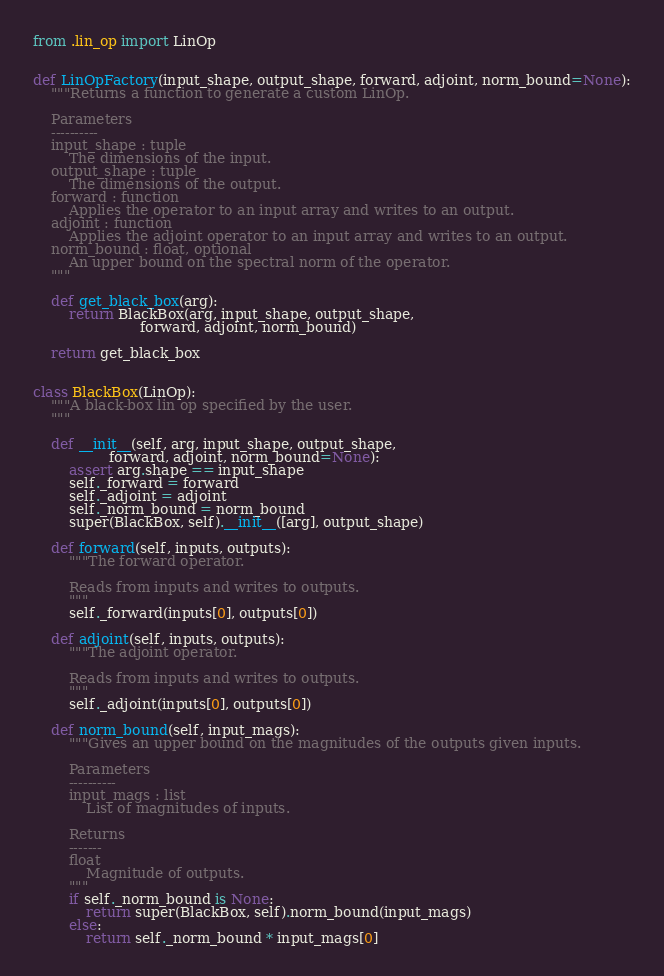<code> <loc_0><loc_0><loc_500><loc_500><_Python_>from .lin_op import LinOp


def LinOpFactory(input_shape, output_shape, forward, adjoint, norm_bound=None):
    """Returns a function to generate a custom LinOp.

    Parameters
    ----------
    input_shape : tuple
        The dimensions of the input.
    output_shape : tuple
        The dimensions of the output.
    forward : function
        Applies the operator to an input array and writes to an output.
    adjoint : function
        Applies the adjoint operator to an input array and writes to an output.
    norm_bound : float, optional
        An upper bound on the spectral norm of the operator.
    """

    def get_black_box(arg):
        return BlackBox(arg, input_shape, output_shape,
                        forward, adjoint, norm_bound)

    return get_black_box


class BlackBox(LinOp):
    """A black-box lin op specified by the user.
    """

    def __init__(self, arg, input_shape, output_shape,
                 forward, adjoint, norm_bound=None):
        assert arg.shape == input_shape
        self._forward = forward
        self._adjoint = adjoint
        self._norm_bound = norm_bound
        super(BlackBox, self).__init__([arg], output_shape)

    def forward(self, inputs, outputs):
        """The forward operator.

        Reads from inputs and writes to outputs.
        """
        self._forward(inputs[0], outputs[0])

    def adjoint(self, inputs, outputs):
        """The adjoint operator.

        Reads from inputs and writes to outputs.
        """
        self._adjoint(inputs[0], outputs[0])

    def norm_bound(self, input_mags):
        """Gives an upper bound on the magnitudes of the outputs given inputs.

        Parameters
        ----------
        input_mags : list
            List of magnitudes of inputs.

        Returns
        -------
        float
            Magnitude of outputs.
        """
        if self._norm_bound is None:
            return super(BlackBox, self).norm_bound(input_mags)
        else:
            return self._norm_bound * input_mags[0]
</code> 